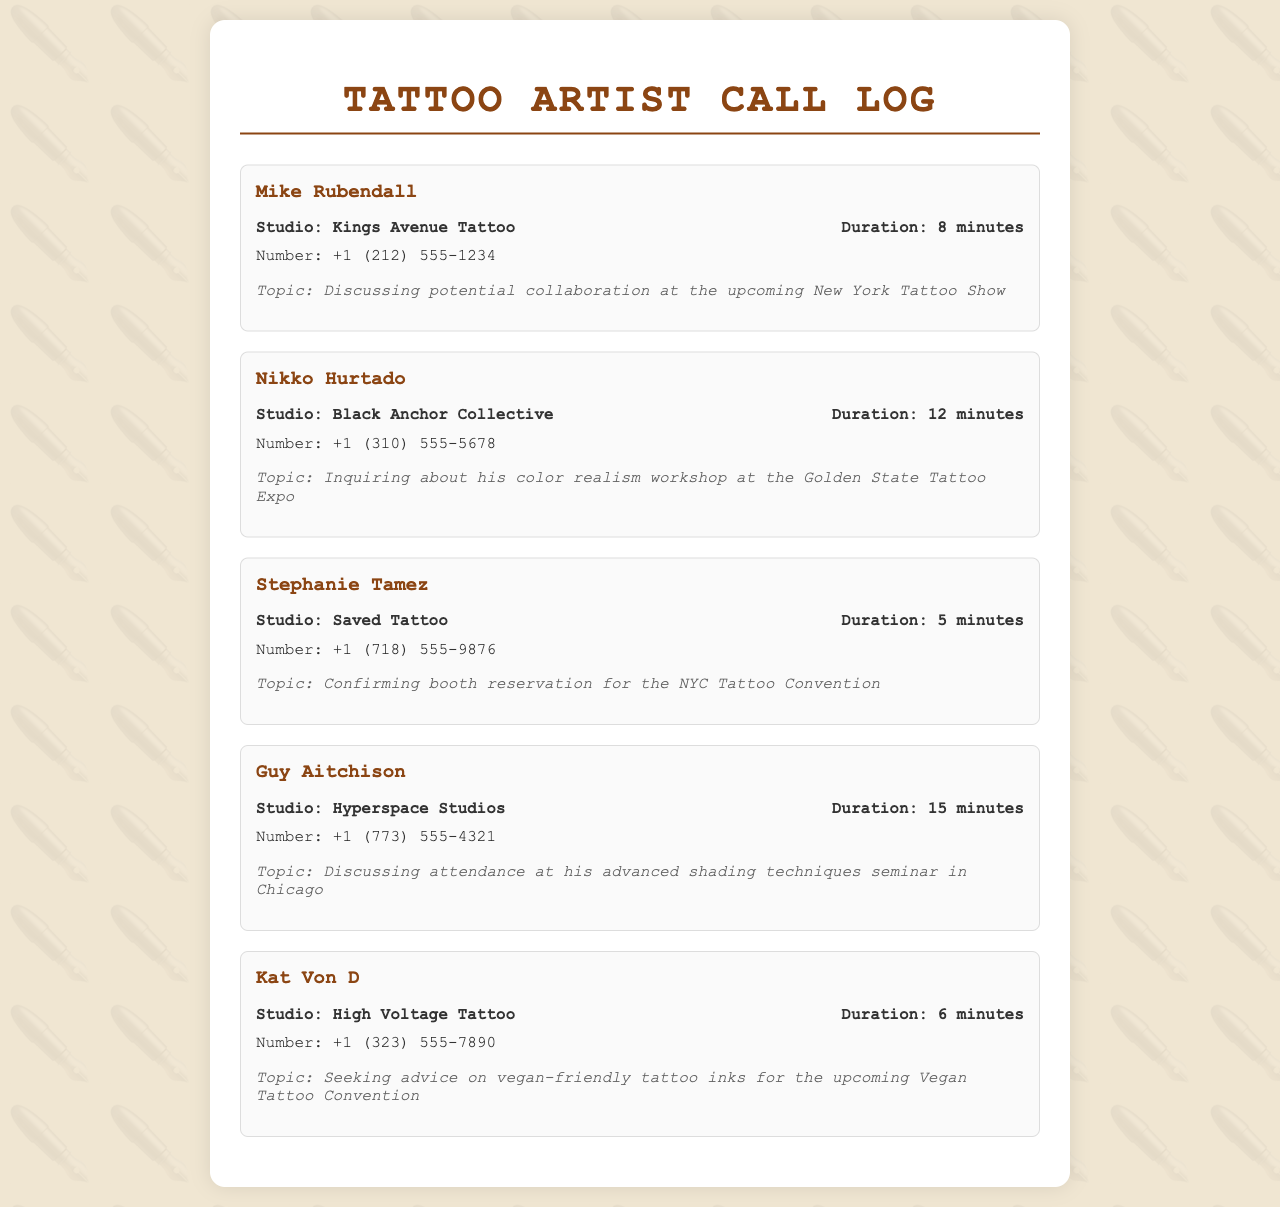what is the name of the first artist mentioned? The first artist listed in the call log is Mike Rubendall.
Answer: Mike Rubendall how long was the call with Nikko Hurtado? The duration of the call with Nikko Hurtado is specified in the document as 12 minutes.
Answer: 12 minutes which convention is Stephanie Tamez confirming booth reservation for? Stephanie Tamez is confirming the booth reservation for the NYC Tattoo Convention.
Answer: NYC Tattoo Convention who is discussing shading techniques in Chicago? Guy Aitchison is the artist discussing his advanced shading techniques seminar in Chicago.
Answer: Guy Aitchison what studio does Kat Von D work at? Kat Von D is associated with High Voltage Tattoo.
Answer: High Voltage Tattoo how many minutes did the call with Mike Rubendall last? The duration of the call with Mike Rubendall is 8 minutes, as stated in the document.
Answer: 8 minutes what topic did the call with Kat Von D address? The call with Kat Von D addressed vegan-friendly tattoo inks for the upcoming Vegan Tattoo Convention.
Answer: vegan-friendly tattoo inks who inquired about a workshop at the Golden State Tattoo Expo? Nikko Hurtado inquired about his color realism workshop at the Golden State Tattoo Expo.
Answer: Nikko Hurtado what is the phone number listed for Guy Aitchison? The phone number for Guy Aitchison is given as +1 (773) 555-4321.
Answer: +1 (773) 555-4321 